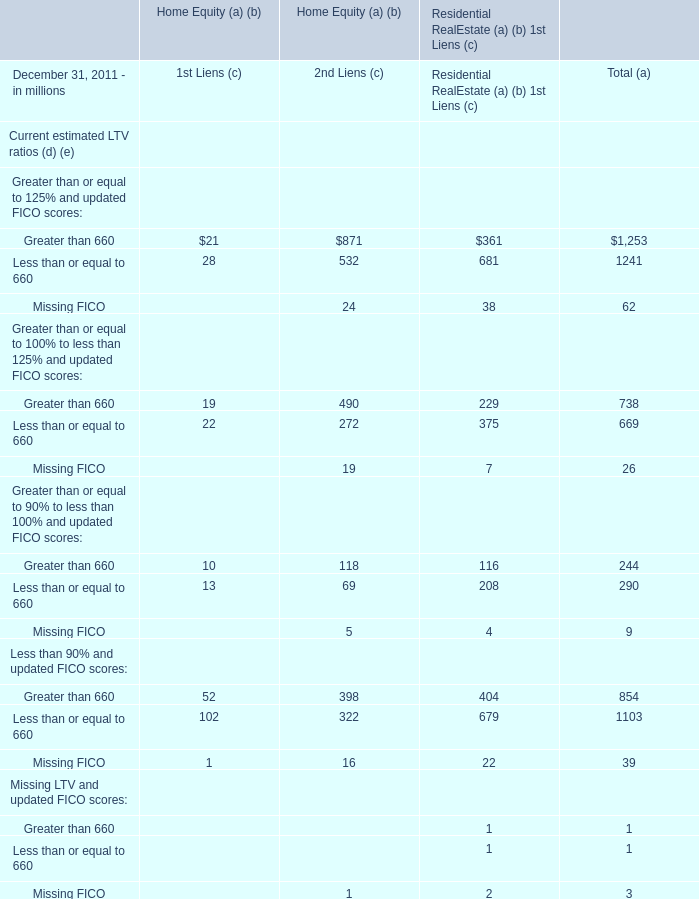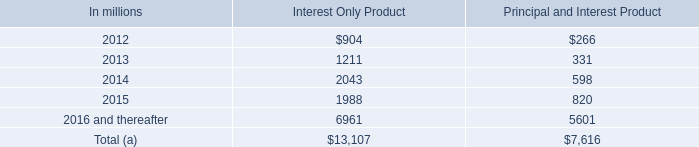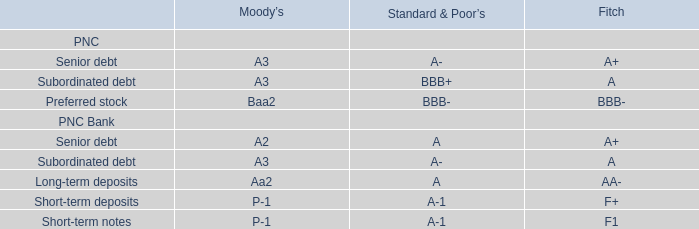What is the ratio of all elements that are in the range of 20 and 50 to the sum of elements for 1st Liens (c)? 
Computations: (((21 + 28) + 22) / 268)
Answer: 0.26493. 